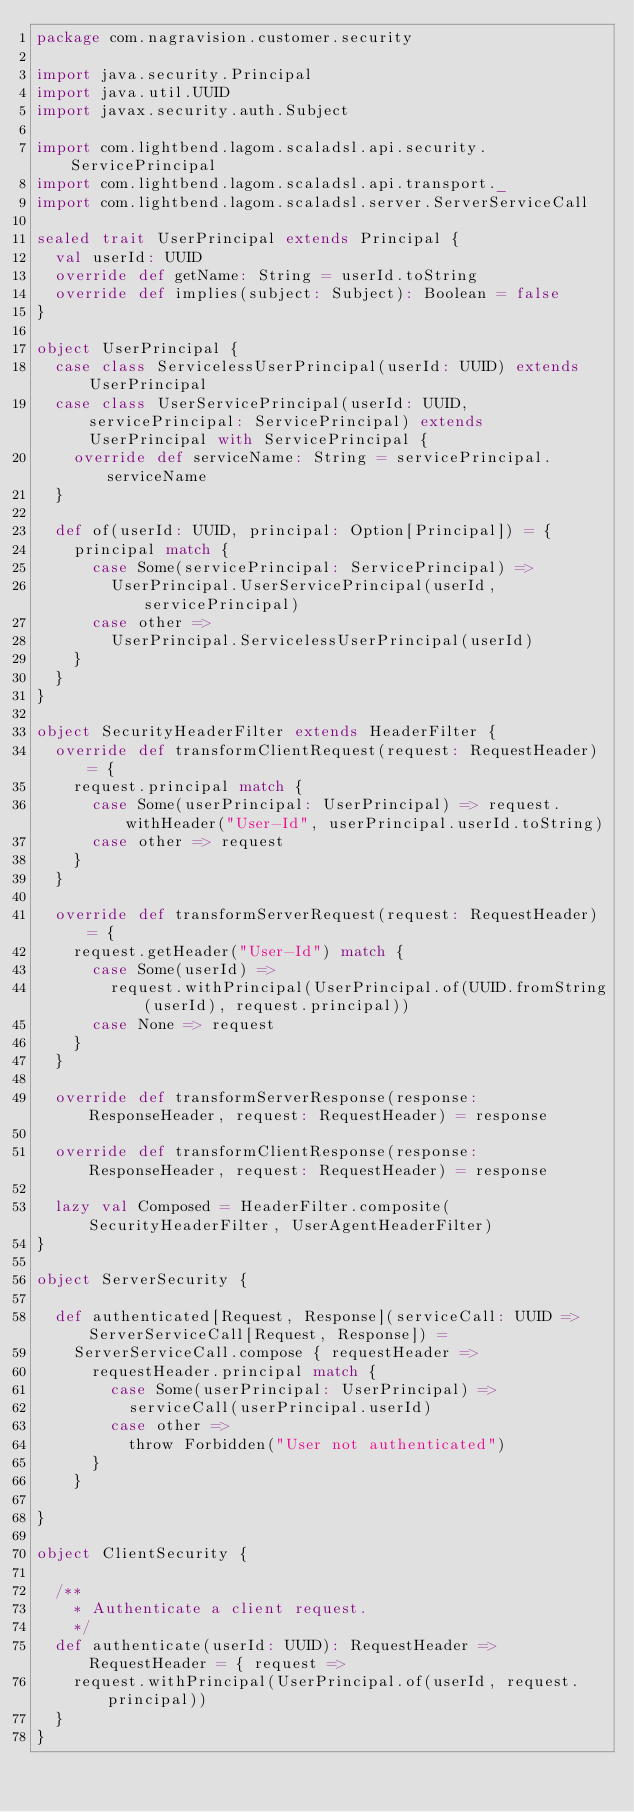Convert code to text. <code><loc_0><loc_0><loc_500><loc_500><_Scala_>package com.nagravision.customer.security

import java.security.Principal
import java.util.UUID
import javax.security.auth.Subject

import com.lightbend.lagom.scaladsl.api.security.ServicePrincipal
import com.lightbend.lagom.scaladsl.api.transport._
import com.lightbend.lagom.scaladsl.server.ServerServiceCall

sealed trait UserPrincipal extends Principal {
  val userId: UUID
  override def getName: String = userId.toString
  override def implies(subject: Subject): Boolean = false
}

object UserPrincipal {
  case class ServicelessUserPrincipal(userId: UUID) extends UserPrincipal
  case class UserServicePrincipal(userId: UUID, servicePrincipal: ServicePrincipal) extends UserPrincipal with ServicePrincipal {
    override def serviceName: String = servicePrincipal.serviceName
  }

  def of(userId: UUID, principal: Option[Principal]) = {
    principal match {
      case Some(servicePrincipal: ServicePrincipal) =>
        UserPrincipal.UserServicePrincipal(userId, servicePrincipal)
      case other =>
        UserPrincipal.ServicelessUserPrincipal(userId)
    }
  }
}

object SecurityHeaderFilter extends HeaderFilter {
  override def transformClientRequest(request: RequestHeader) = {
    request.principal match {
      case Some(userPrincipal: UserPrincipal) => request.withHeader("User-Id", userPrincipal.userId.toString)
      case other => request
    }
  }

  override def transformServerRequest(request: RequestHeader) = {
    request.getHeader("User-Id") match {
      case Some(userId) =>
        request.withPrincipal(UserPrincipal.of(UUID.fromString(userId), request.principal))
      case None => request
    }
  }

  override def transformServerResponse(response: ResponseHeader, request: RequestHeader) = response

  override def transformClientResponse(response: ResponseHeader, request: RequestHeader) = response

  lazy val Composed = HeaderFilter.composite(SecurityHeaderFilter, UserAgentHeaderFilter)
}

object ServerSecurity {

  def authenticated[Request, Response](serviceCall: UUID => ServerServiceCall[Request, Response]) =
    ServerServiceCall.compose { requestHeader =>
      requestHeader.principal match {
        case Some(userPrincipal: UserPrincipal) =>
          serviceCall(userPrincipal.userId)
        case other =>
          throw Forbidden("User not authenticated")
      }
    }

}

object ClientSecurity {

  /**
    * Authenticate a client request.
    */
  def authenticate(userId: UUID): RequestHeader => RequestHeader = { request =>
    request.withPrincipal(UserPrincipal.of(userId, request.principal))
  }
}



</code> 